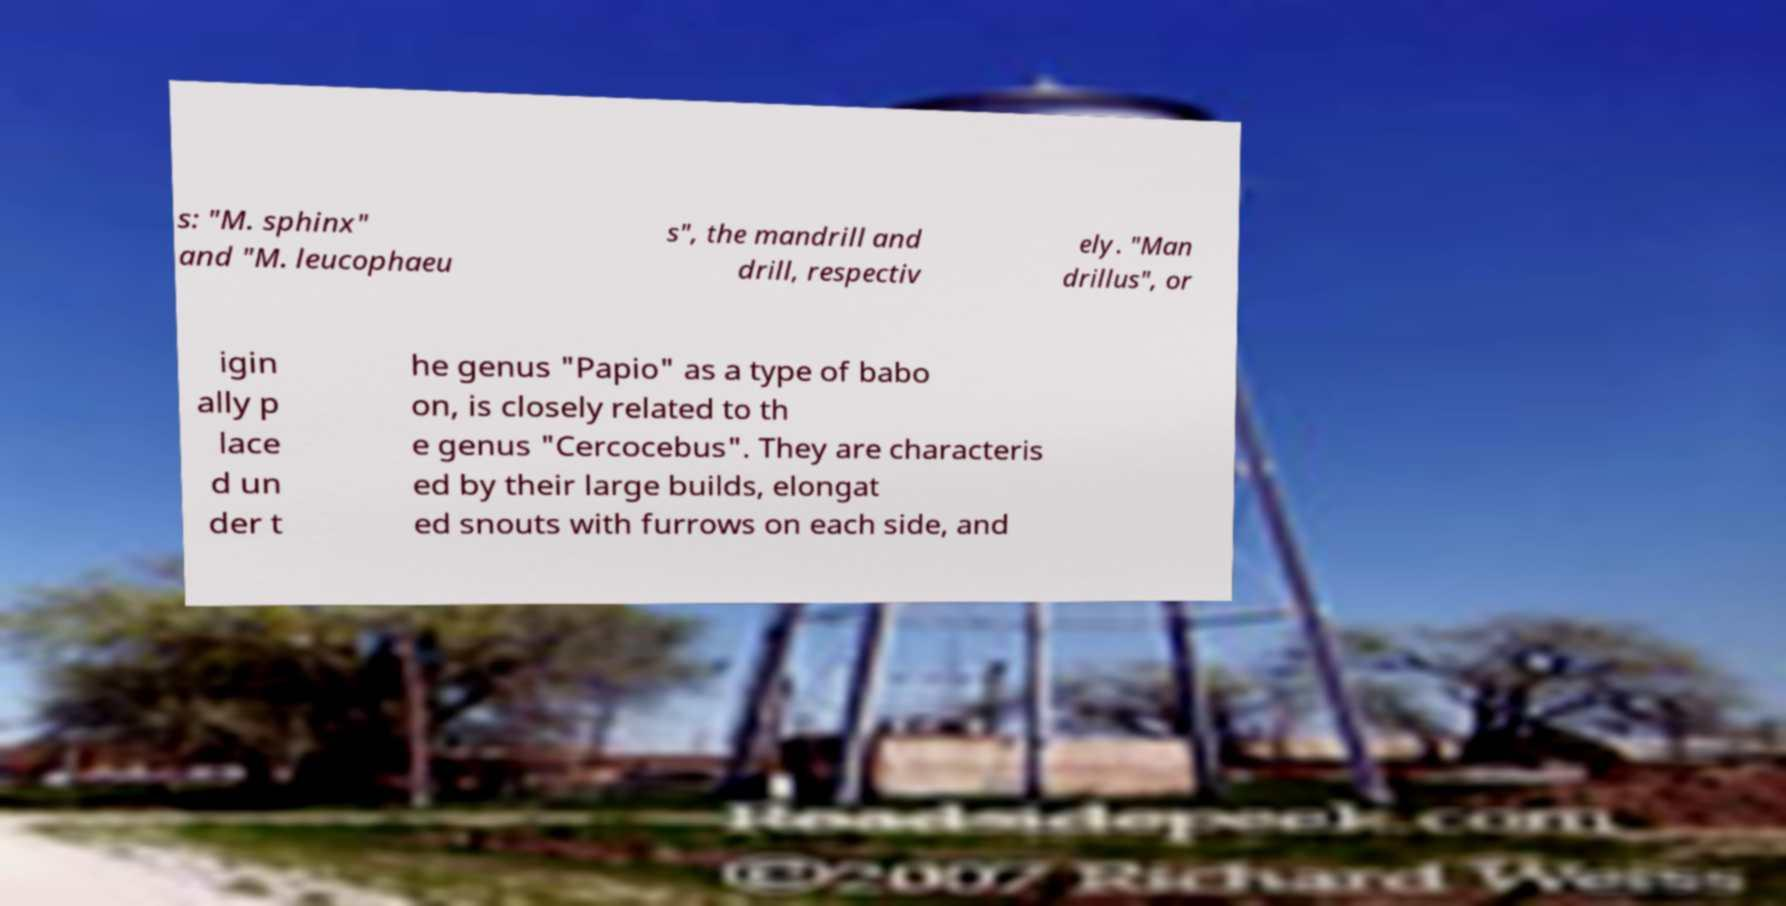Can you read and provide the text displayed in the image?This photo seems to have some interesting text. Can you extract and type it out for me? s: "M. sphinx" and "M. leucophaeu s", the mandrill and drill, respectiv ely. "Man drillus", or igin ally p lace d un der t he genus "Papio" as a type of babo on, is closely related to th e genus "Cercocebus". They are characteris ed by their large builds, elongat ed snouts with furrows on each side, and 